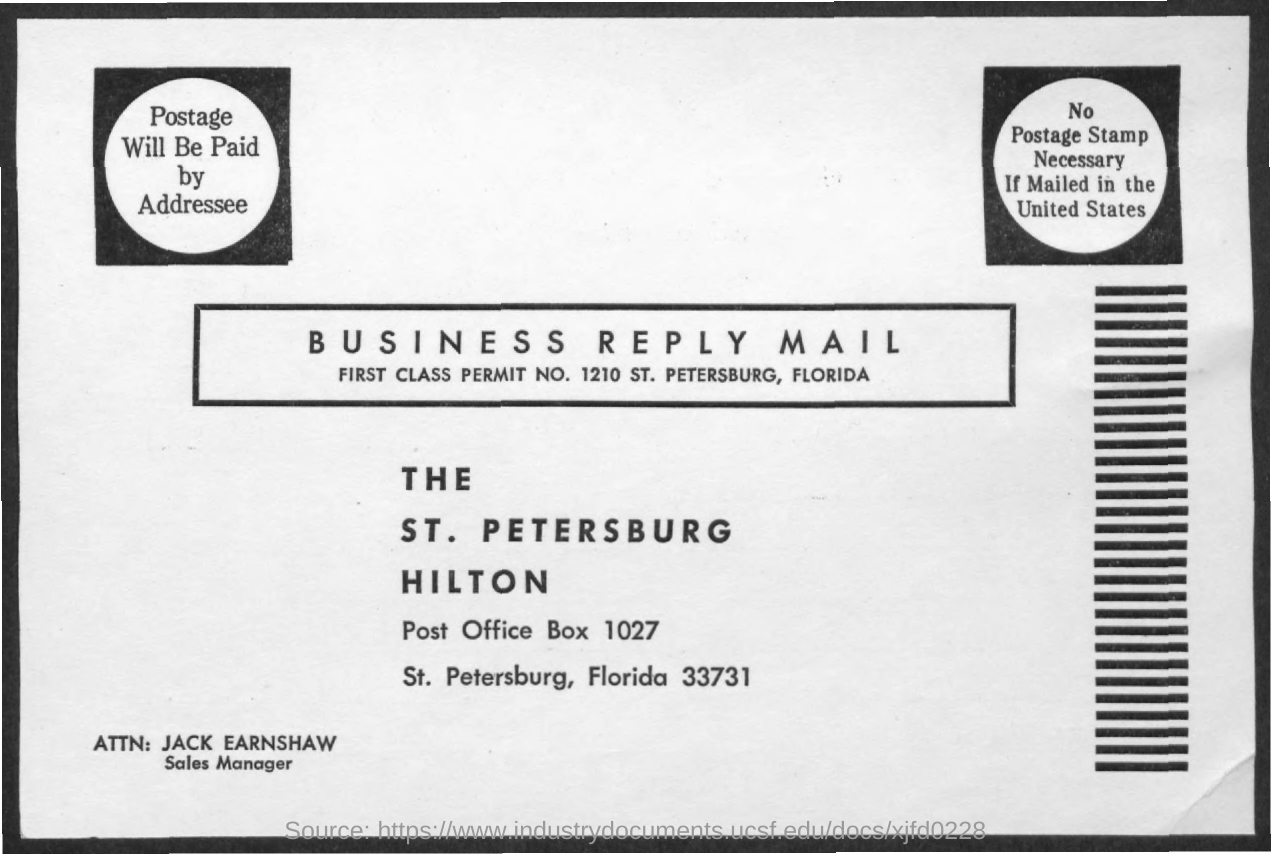What is the first class permit no. mentioned in the business reply mail?
Your response must be concise. 1210. What is the Post office Box No. given in the address?
Provide a short and direct response. 1027. What is the designation of JACK EARNSHAW?
Your response must be concise. Sales Manager. 